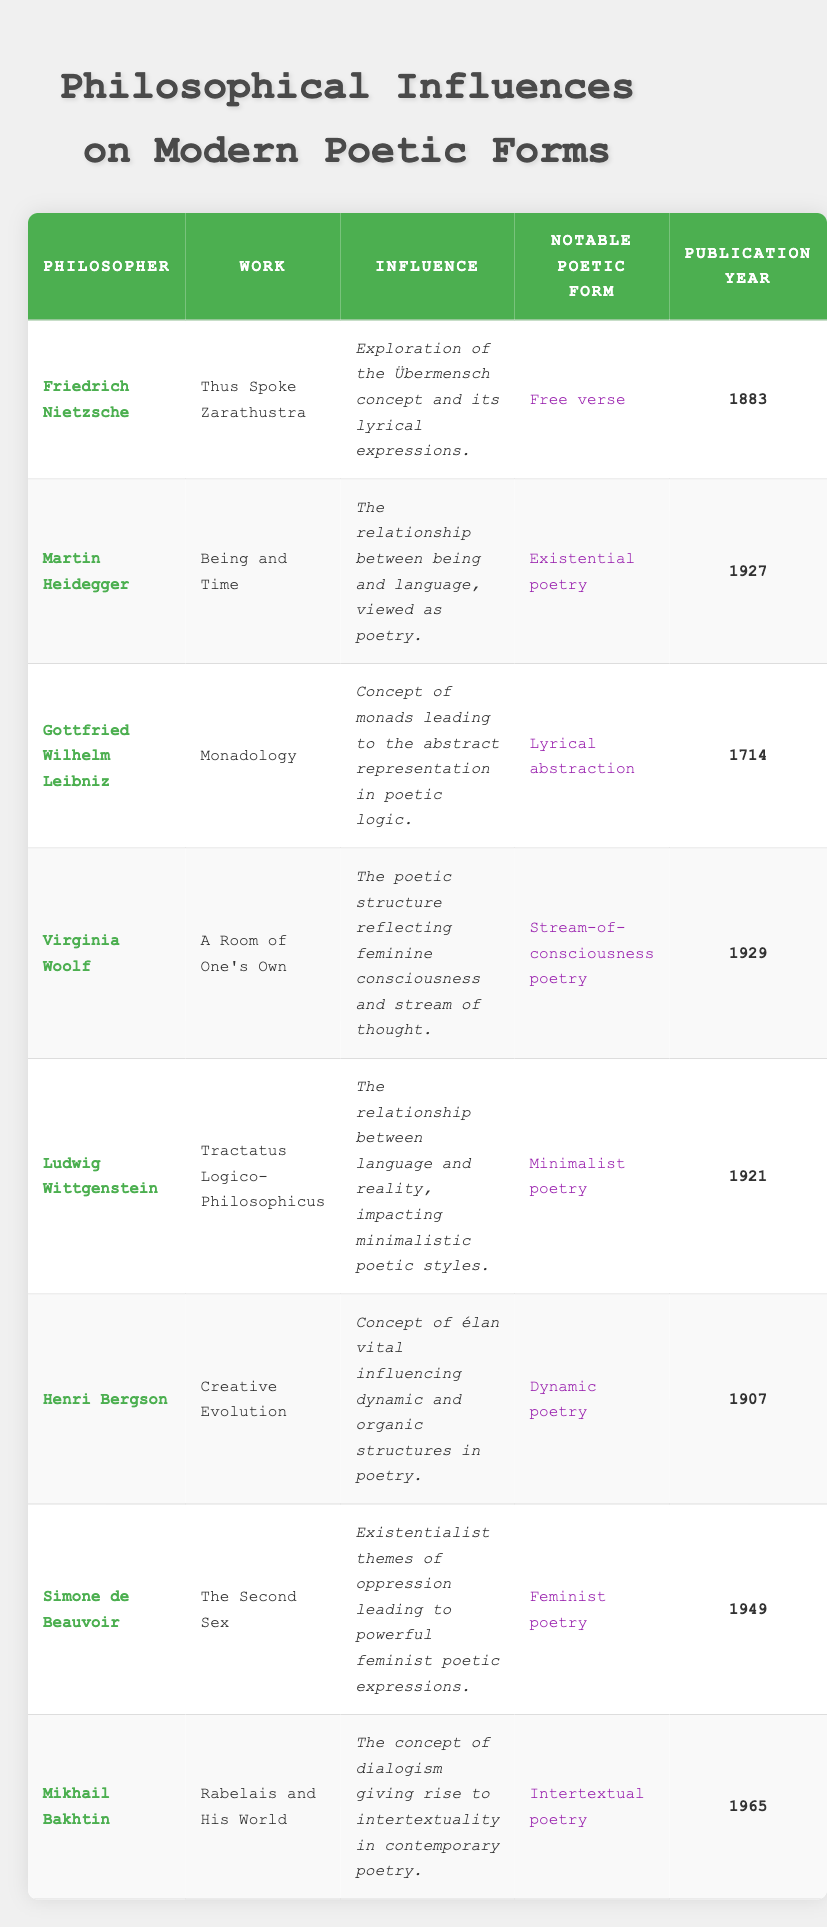What philosophical work was published in 1927? From the table, we look for the entry with the publication year of 1927. The work "Being and Time" by Martin Heidegger corresponds to that year.
Answer: Being and Time Which poetic form is associated with Friedrich Nietzsche? In the table, under Friedrich Nietzsche's row, the column for "Notable Poetic Form" shows "Free verse."
Answer: Free verse How many philosophers contributed to the evolution of poetic forms before the 20th century? By examining the publication years in the table, there are three entries before 1900: Gottfried Wilhelm Leibniz (1714), Friedrich Nietzsche (1883), and Henri Bergson (1907). Thus, we count 3 philosophers.
Answer: 3 Is it true that Simone de Beauvoir influenced feminist poetry? The table indicates under her entry that her work "The Second Sex" led to "powerful feminist poetic expressions." This confirms the statement as true.
Answer: Yes Which notable poetic form is connected to the work "Rabelais and His World"? By finding Mikhail Bakhtin's entry in the table, we see that the associated poetic form listed is "Intertextual poetry."
Answer: Intertextual poetry What year does the earliest philosophy work influencing modern poetry belong to? Looking across the publication years in the table, the earliest entry is for "Monadology" by Gottfried Wilhelm Leibniz from the year 1714.
Answer: 1714 After 1940, what types of poetry are influenced by philosophers according to the table? Observing the entries, we note that only Simone de Beauvoir's feminist poetry (1949) and Mikhail Bakhtin's intertextual poetry (1965) fall into this range. Thus, we have two types: feminist poetry and intertextual poetry.
Answer: Feminist poetry, Intertextual poetry What is the average publication year of the works listed in the table? The publication years in the table are 1883, 1927, 1714, 1929, 1921, 1907, 1949, and 1965. To find the average, first, sum them up: 1883 + 1927 + 1714 + 1929 + 1921 + 1907 + 1949 + 1965 = 15095. Then divide by the number of works (8): 15095 / 8 = 1886.875, which rounds to 1887.
Answer: 1887 